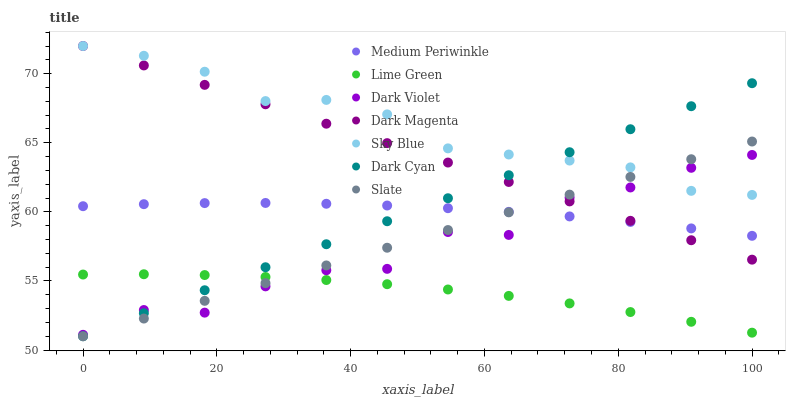Does Lime Green have the minimum area under the curve?
Answer yes or no. Yes. Does Sky Blue have the maximum area under the curve?
Answer yes or no. Yes. Does Slate have the minimum area under the curve?
Answer yes or no. No. Does Slate have the maximum area under the curve?
Answer yes or no. No. Is Dark Magenta the smoothest?
Answer yes or no. Yes. Is Dark Violet the roughest?
Answer yes or no. Yes. Is Slate the smoothest?
Answer yes or no. No. Is Slate the roughest?
Answer yes or no. No. Does Slate have the lowest value?
Answer yes or no. Yes. Does Medium Periwinkle have the lowest value?
Answer yes or no. No. Does Sky Blue have the highest value?
Answer yes or no. Yes. Does Slate have the highest value?
Answer yes or no. No. Is Lime Green less than Sky Blue?
Answer yes or no. Yes. Is Sky Blue greater than Medium Periwinkle?
Answer yes or no. Yes. Does Dark Violet intersect Medium Periwinkle?
Answer yes or no. Yes. Is Dark Violet less than Medium Periwinkle?
Answer yes or no. No. Is Dark Violet greater than Medium Periwinkle?
Answer yes or no. No. Does Lime Green intersect Sky Blue?
Answer yes or no. No. 